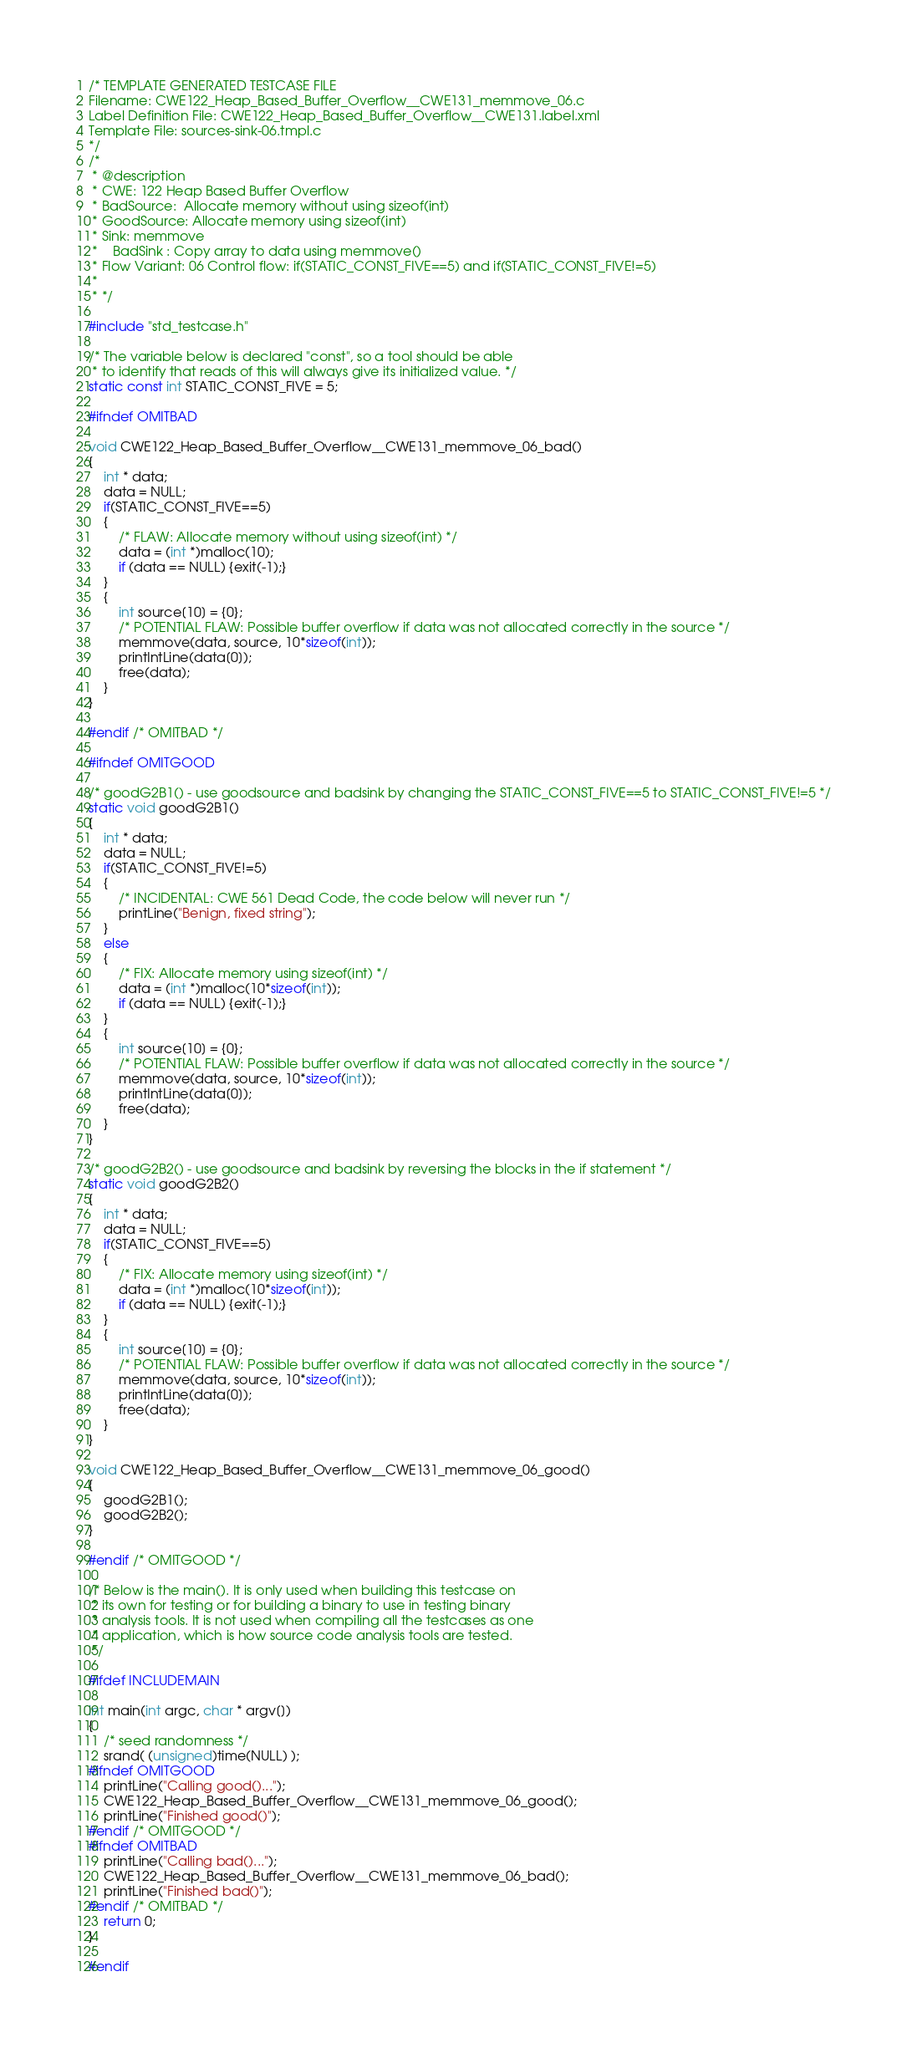Convert code to text. <code><loc_0><loc_0><loc_500><loc_500><_C_>/* TEMPLATE GENERATED TESTCASE FILE
Filename: CWE122_Heap_Based_Buffer_Overflow__CWE131_memmove_06.c
Label Definition File: CWE122_Heap_Based_Buffer_Overflow__CWE131.label.xml
Template File: sources-sink-06.tmpl.c
*/
/*
 * @description
 * CWE: 122 Heap Based Buffer Overflow
 * BadSource:  Allocate memory without using sizeof(int)
 * GoodSource: Allocate memory using sizeof(int)
 * Sink: memmove
 *    BadSink : Copy array to data using memmove()
 * Flow Variant: 06 Control flow: if(STATIC_CONST_FIVE==5) and if(STATIC_CONST_FIVE!=5)
 *
 * */

#include "std_testcase.h"

/* The variable below is declared "const", so a tool should be able
 * to identify that reads of this will always give its initialized value. */
static const int STATIC_CONST_FIVE = 5;

#ifndef OMITBAD

void CWE122_Heap_Based_Buffer_Overflow__CWE131_memmove_06_bad()
{
    int * data;
    data = NULL;
    if(STATIC_CONST_FIVE==5)
    {
        /* FLAW: Allocate memory without using sizeof(int) */
        data = (int *)malloc(10);
        if (data == NULL) {exit(-1);}
    }
    {
        int source[10] = {0};
        /* POTENTIAL FLAW: Possible buffer overflow if data was not allocated correctly in the source */
        memmove(data, source, 10*sizeof(int));
        printIntLine(data[0]);
        free(data);
    }
}

#endif /* OMITBAD */

#ifndef OMITGOOD

/* goodG2B1() - use goodsource and badsink by changing the STATIC_CONST_FIVE==5 to STATIC_CONST_FIVE!=5 */
static void goodG2B1()
{
    int * data;
    data = NULL;
    if(STATIC_CONST_FIVE!=5)
    {
        /* INCIDENTAL: CWE 561 Dead Code, the code below will never run */
        printLine("Benign, fixed string");
    }
    else
    {
        /* FIX: Allocate memory using sizeof(int) */
        data = (int *)malloc(10*sizeof(int));
        if (data == NULL) {exit(-1);}
    }
    {
        int source[10] = {0};
        /* POTENTIAL FLAW: Possible buffer overflow if data was not allocated correctly in the source */
        memmove(data, source, 10*sizeof(int));
        printIntLine(data[0]);
        free(data);
    }
}

/* goodG2B2() - use goodsource and badsink by reversing the blocks in the if statement */
static void goodG2B2()
{
    int * data;
    data = NULL;
    if(STATIC_CONST_FIVE==5)
    {
        /* FIX: Allocate memory using sizeof(int) */
        data = (int *)malloc(10*sizeof(int));
        if (data == NULL) {exit(-1);}
    }
    {
        int source[10] = {0};
        /* POTENTIAL FLAW: Possible buffer overflow if data was not allocated correctly in the source */
        memmove(data, source, 10*sizeof(int));
        printIntLine(data[0]);
        free(data);
    }
}

void CWE122_Heap_Based_Buffer_Overflow__CWE131_memmove_06_good()
{
    goodG2B1();
    goodG2B2();
}

#endif /* OMITGOOD */

/* Below is the main(). It is only used when building this testcase on
 * its own for testing or for building a binary to use in testing binary
 * analysis tools. It is not used when compiling all the testcases as one
 * application, which is how source code analysis tools are tested.
 */

#ifdef INCLUDEMAIN

int main(int argc, char * argv[])
{
    /* seed randomness */
    srand( (unsigned)time(NULL) );
#ifndef OMITGOOD
    printLine("Calling good()...");
    CWE122_Heap_Based_Buffer_Overflow__CWE131_memmove_06_good();
    printLine("Finished good()");
#endif /* OMITGOOD */
#ifndef OMITBAD
    printLine("Calling bad()...");
    CWE122_Heap_Based_Buffer_Overflow__CWE131_memmove_06_bad();
    printLine("Finished bad()");
#endif /* OMITBAD */
    return 0;
}

#endif
</code> 